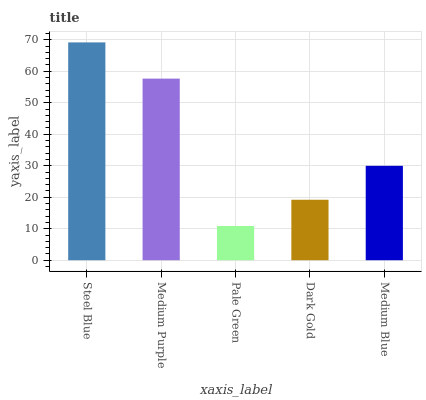Is Pale Green the minimum?
Answer yes or no. Yes. Is Steel Blue the maximum?
Answer yes or no. Yes. Is Medium Purple the minimum?
Answer yes or no. No. Is Medium Purple the maximum?
Answer yes or no. No. Is Steel Blue greater than Medium Purple?
Answer yes or no. Yes. Is Medium Purple less than Steel Blue?
Answer yes or no. Yes. Is Medium Purple greater than Steel Blue?
Answer yes or no. No. Is Steel Blue less than Medium Purple?
Answer yes or no. No. Is Medium Blue the high median?
Answer yes or no. Yes. Is Medium Blue the low median?
Answer yes or no. Yes. Is Pale Green the high median?
Answer yes or no. No. Is Steel Blue the low median?
Answer yes or no. No. 